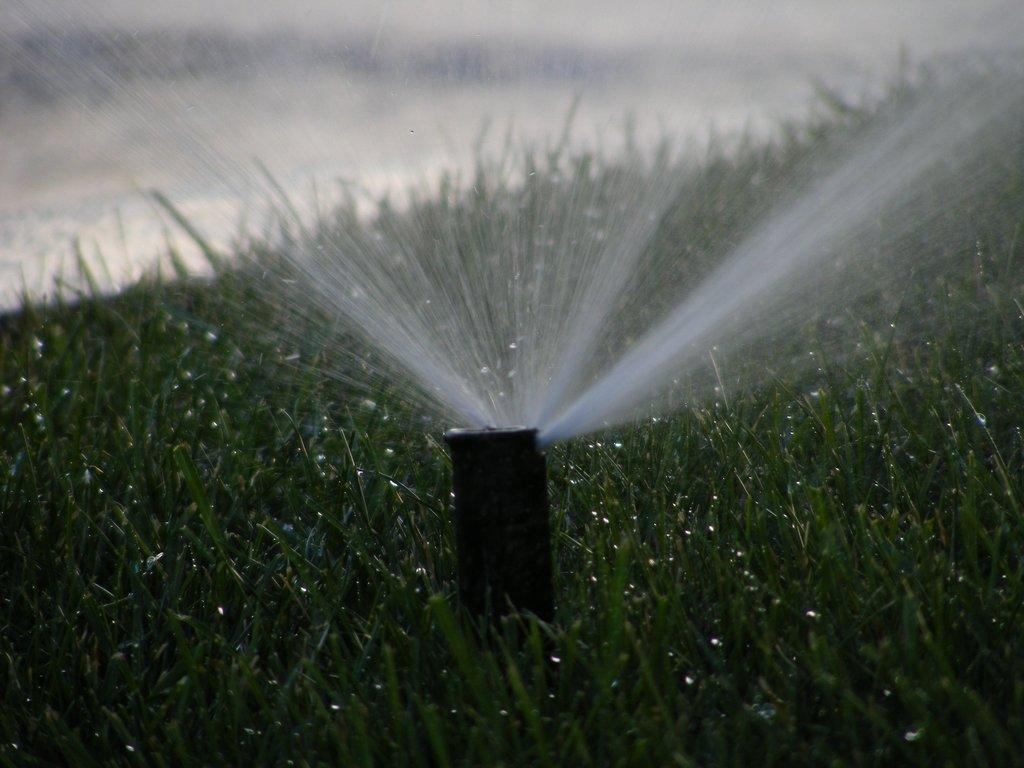What is located in the middle of the grass in the image? There is a pole in the middle of the grass. What is the pole doing in the image? Water is coming out of the pole. What type of steel is used to make the statement in the song in the image? There is no steel, statement, or song present in the image; it only features a pole with water coming out of it. 